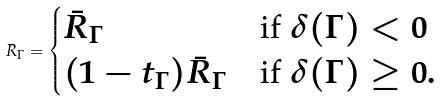Convert formula to latex. <formula><loc_0><loc_0><loc_500><loc_500>R _ { \Gamma } = \begin{cases} \bar { R } _ { \Gamma } & \text {if $\delta(\Gamma)<0$} \\ ( 1 - t _ { \Gamma } ) \bar { R } _ { \Gamma } & \text {if $\delta(\Gamma) \geq 0$} . \end{cases}</formula> 